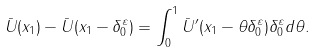<formula> <loc_0><loc_0><loc_500><loc_500>\bar { U } ( x _ { 1 } ) - \bar { U } ( x _ { 1 } - \delta _ { 0 } ^ { \varepsilon } ) = \int _ { 0 } ^ { 1 } \bar { U } ^ { \prime } ( x _ { 1 } - \theta \delta _ { 0 } ^ { \varepsilon } ) \delta _ { 0 } ^ { \varepsilon } d \theta .</formula> 